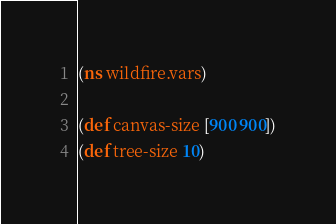<code> <loc_0><loc_0><loc_500><loc_500><_Clojure_>(ns wildfire.vars)

(def canvas-size [900 900])
(def tree-size 10)</code> 